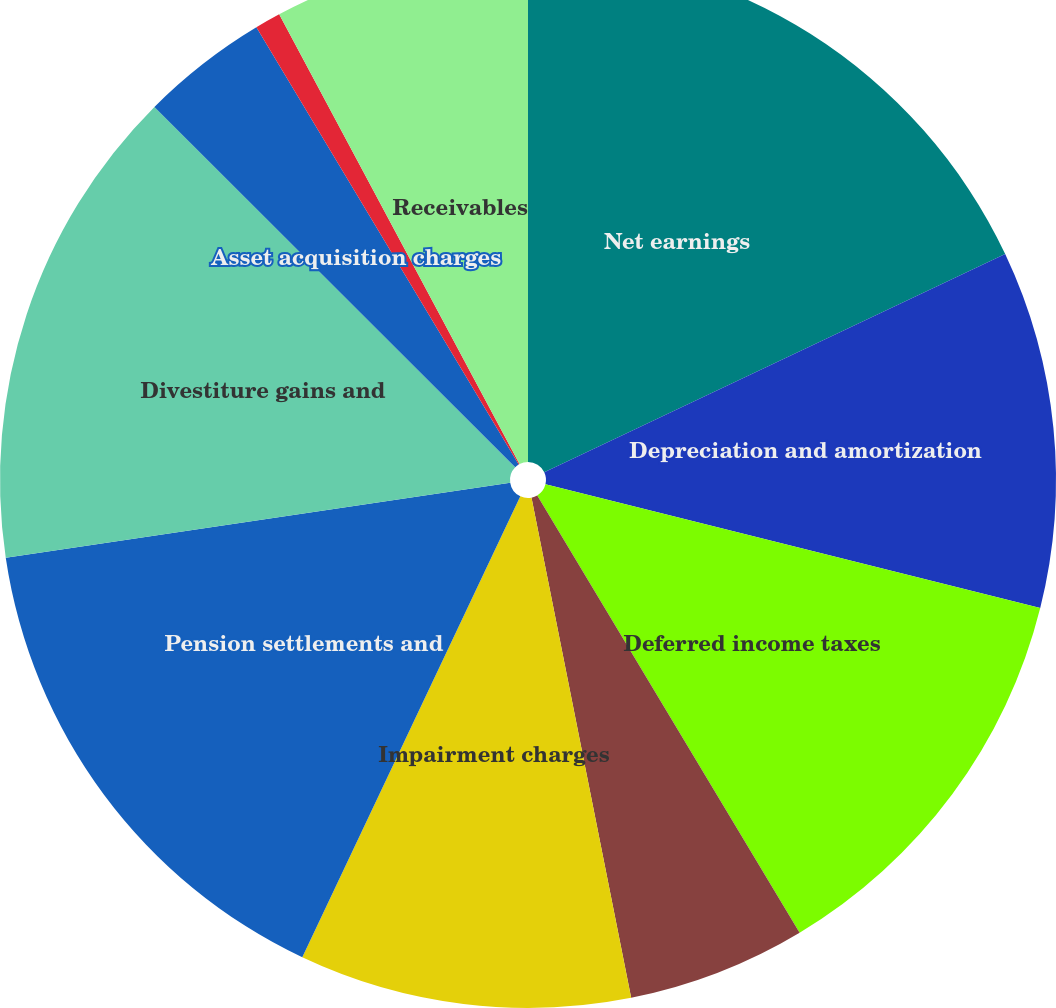Convert chart. <chart><loc_0><loc_0><loc_500><loc_500><pie_chart><fcel>Net earnings<fcel>Depreciation and amortization<fcel>Deferred income taxes<fcel>Stock-based compensation<fcel>Impairment charges<fcel>Pension settlements and<fcel>Divestiture gains and<fcel>Asset acquisition charges<fcel>Other adjustments<fcel>Receivables<nl><fcel>17.96%<fcel>10.94%<fcel>12.5%<fcel>5.47%<fcel>10.16%<fcel>15.62%<fcel>14.84%<fcel>3.91%<fcel>0.79%<fcel>7.81%<nl></chart> 